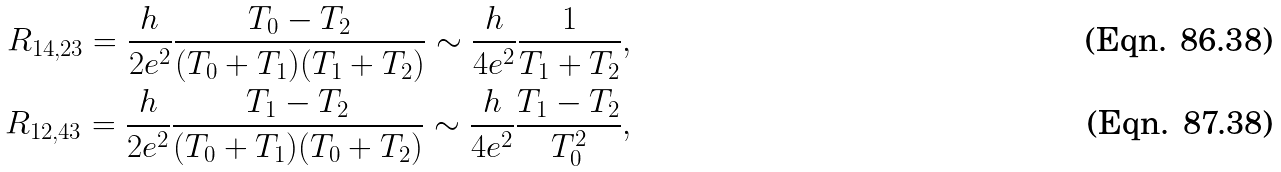<formula> <loc_0><loc_0><loc_500><loc_500>R _ { 1 4 , 2 3 } = \frac { h } { 2 e ^ { 2 } } \frac { T _ { 0 } - T _ { 2 } } { ( T _ { 0 } + T _ { 1 } ) ( T _ { 1 } + T _ { 2 } ) } \sim \frac { h } { 4 e ^ { 2 } } \frac { 1 } { T _ { 1 } + T _ { 2 } } , \\ R _ { 1 2 , 4 3 } = \frac { h } { 2 e ^ { 2 } } \frac { T _ { 1 } - T _ { 2 } } { ( T _ { 0 } + T _ { 1 } ) ( T _ { 0 } + T _ { 2 } ) } \sim \frac { h } { 4 e ^ { 2 } } \frac { T _ { 1 } - T _ { 2 } } { T _ { 0 } ^ { 2 } } ,</formula> 